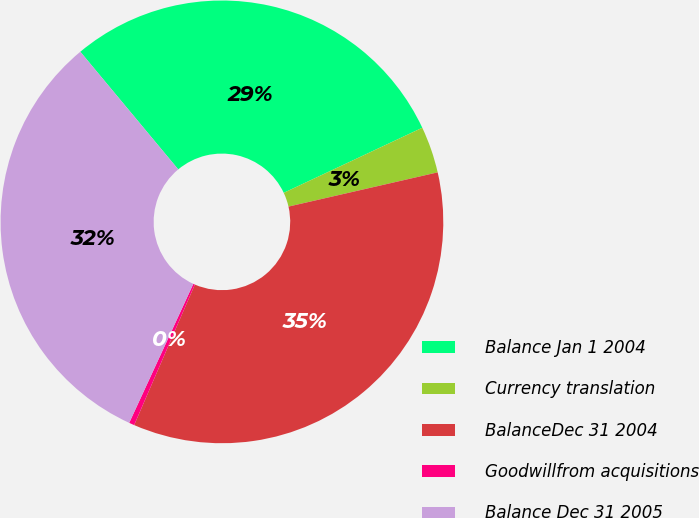Convert chart to OTSL. <chart><loc_0><loc_0><loc_500><loc_500><pie_chart><fcel>Balance Jan 1 2004<fcel>Currency translation<fcel>BalanceDec 31 2004<fcel>Goodwillfrom acquisitions<fcel>Balance Dec 31 2005<nl><fcel>29.06%<fcel>3.4%<fcel>35.08%<fcel>0.39%<fcel>32.07%<nl></chart> 